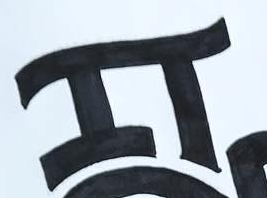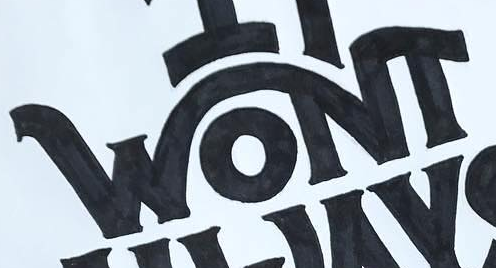Identify the words shown in these images in order, separated by a semicolon. IT; WONT 